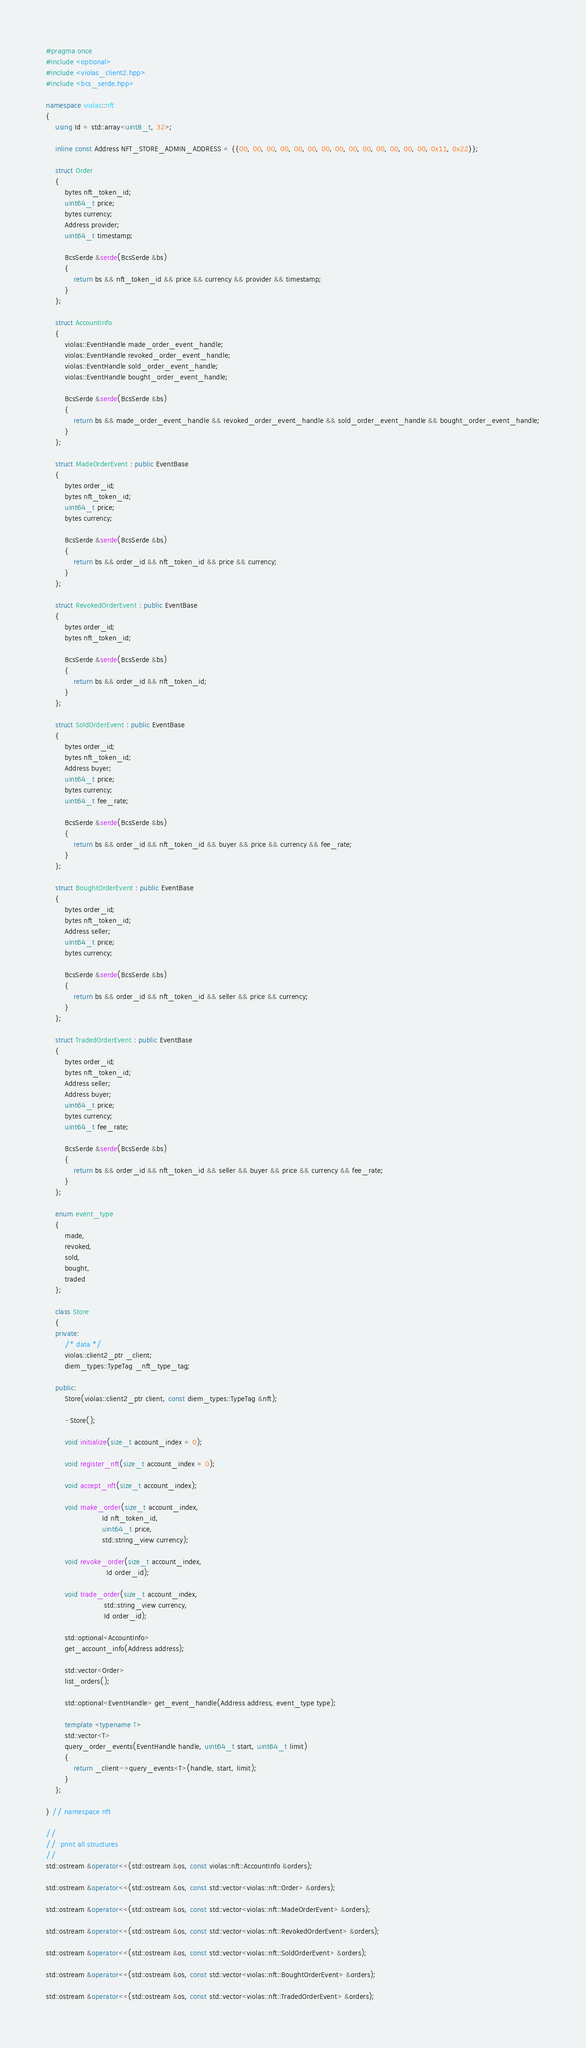Convert code to text. <code><loc_0><loc_0><loc_500><loc_500><_C++_>#pragma once
#include <optional>
#include <violas_client2.hpp>
#include <bcs_serde.hpp>

namespace violas::nft
{
    using Id = std::array<uint8_t, 32>;

    inline const Address NFT_STORE_ADMIN_ADDRESS = {{00, 00, 00, 00, 00, 00, 00, 00, 00, 00, 00, 00, 00, 00, 0x11, 0x22}};

    struct Order
    {
        bytes nft_token_id;
        uint64_t price;
        bytes currency;
        Address provider;
        uint64_t timestamp;

        BcsSerde &serde(BcsSerde &bs)
        {
            return bs && nft_token_id && price && currency && provider && timestamp;
        }
    };

    struct AccountInfo
    {
        violas::EventHandle made_order_event_handle;
        violas::EventHandle revoked_order_event_handle;
        violas::EventHandle sold_order_event_handle;
        violas::EventHandle bought_order_event_handle;

        BcsSerde &serde(BcsSerde &bs)
        {
            return bs && made_order_event_handle && revoked_order_event_handle && sold_order_event_handle && bought_order_event_handle;
        }
    };

    struct MadeOrderEvent : public EventBase
    {
        bytes order_id;
        bytes nft_token_id;
        uint64_t price;
        bytes currency;

        BcsSerde &serde(BcsSerde &bs)
        {
            return bs && order_id && nft_token_id && price && currency;
        }
    };

    struct RevokedOrderEvent : public EventBase
    {
        bytes order_id;
        bytes nft_token_id;

        BcsSerde &serde(BcsSerde &bs)
        {
            return bs && order_id && nft_token_id;
        }
    };

    struct SoldOrderEvent : public EventBase
    {
        bytes order_id;
        bytes nft_token_id;
        Address buyer;
        uint64_t price;
        bytes currency;
        uint64_t fee_rate;

        BcsSerde &serde(BcsSerde &bs)
        {
            return bs && order_id && nft_token_id && buyer && price && currency && fee_rate;
        }
    };

    struct BoughtOrderEvent : public EventBase
    {
        bytes order_id;
        bytes nft_token_id;
        Address seller;
        uint64_t price;
        bytes currency;

        BcsSerde &serde(BcsSerde &bs)
        {
            return bs && order_id && nft_token_id && seller && price && currency;
        }
    };

    struct TradedOrderEvent : public EventBase
    {
        bytes order_id;
        bytes nft_token_id;
        Address seller;
        Address buyer;
        uint64_t price;
        bytes currency;
        uint64_t fee_rate;

        BcsSerde &serde(BcsSerde &bs)
        {
            return bs && order_id && nft_token_id && seller && buyer && price && currency && fee_rate;
        }
    };

    enum event_type
    {
        made,
        revoked,
        sold,
        bought,
        traded
    };

    class Store
    {
    private:
        /* data */
        violas::client2_ptr _client;
        diem_types::TypeTag _nft_type_tag;

    public:
        Store(violas::client2_ptr client, const diem_types::TypeTag &nft);

        ~Store();

        void initialize(size_t account_index = 0);

        void register_nft(size_t account_index = 0);

        void accept_nft(size_t account_index);

        void make_order(size_t account_index,
                        Id nft_token_id,
                        uint64_t price,
                        std::string_view currency);

        void revoke_order(size_t account_index,
                          Id order_id);

        void trade_order(size_t account_index,
                         std::string_view currency,
                         Id order_id);

        std::optional<AccountInfo>
        get_account_info(Address address);

        std::vector<Order>
        list_orders();

        std::optional<EventHandle> get_event_handle(Address address, event_type type);

        template <typename T>
        std::vector<T>
        query_order_events(EventHandle handle, uint64_t start, uint64_t limit)
        {
            return _client->query_events<T>(handle, start, limit);
        }
    };

} // namespace nft

//
//  print all structures
//
std::ostream &operator<<(std::ostream &os, const violas::nft::AccountInfo &orders);

std::ostream &operator<<(std::ostream &os, const std::vector<violas::nft::Order> &orders);

std::ostream &operator<<(std::ostream &os, const std::vector<violas::nft::MadeOrderEvent> &orders);

std::ostream &operator<<(std::ostream &os, const std::vector<violas::nft::RevokedOrderEvent> &orders);

std::ostream &operator<<(std::ostream &os, const std::vector<violas::nft::SoldOrderEvent> &orders);

std::ostream &operator<<(std::ostream &os, const std::vector<violas::nft::BoughtOrderEvent> &orders);

std::ostream &operator<<(std::ostream &os, const std::vector<violas::nft::TradedOrderEvent> &orders);</code> 